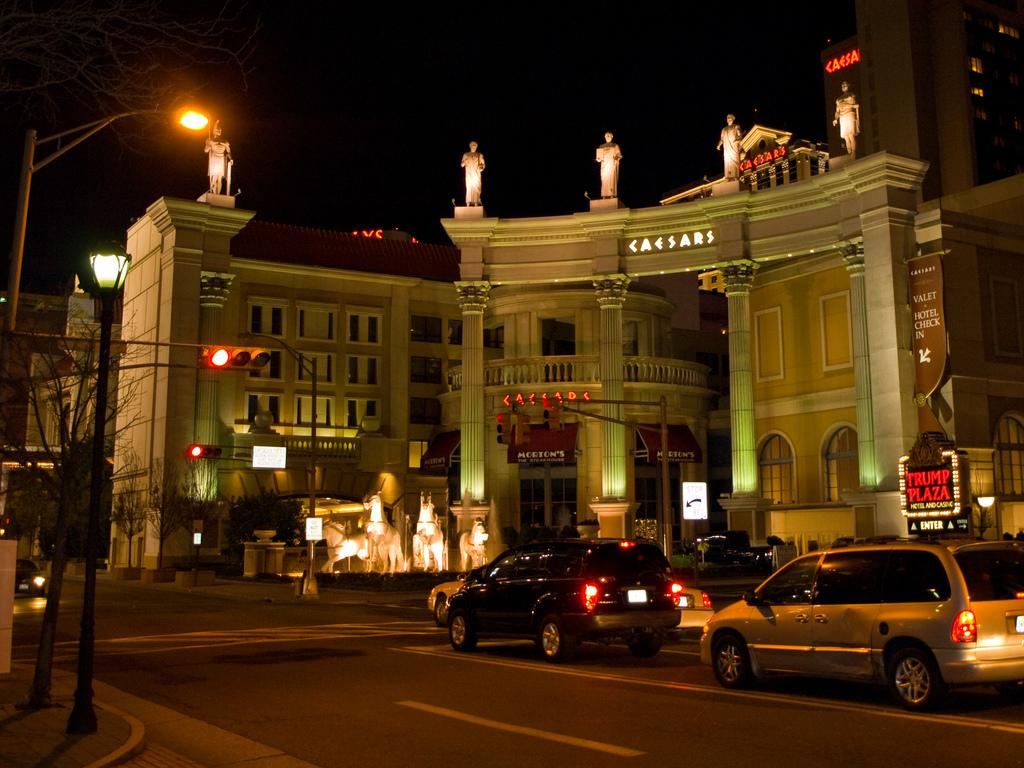<image>
Relay a brief, clear account of the picture shown. On a dark night, neon signs identify locations like Trump Plaza and Caesars. 